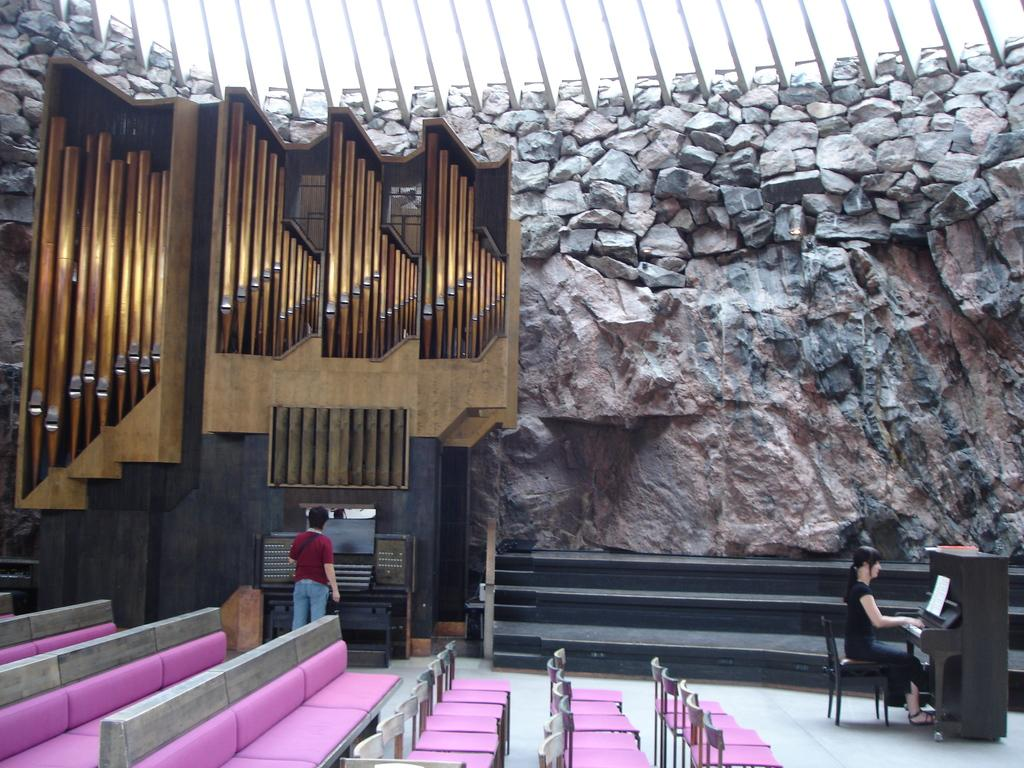What is the man doing in the image? The man is standing in the image. What is the woman doing in the image? The woman is seated and playing the piano in the image. What type of furniture is present in the image? There are chairs and a sofa in the image. What type of thread is being used to create the home in the image? There is no home or thread present in the image; it features a man standing and a woman playing the piano. 